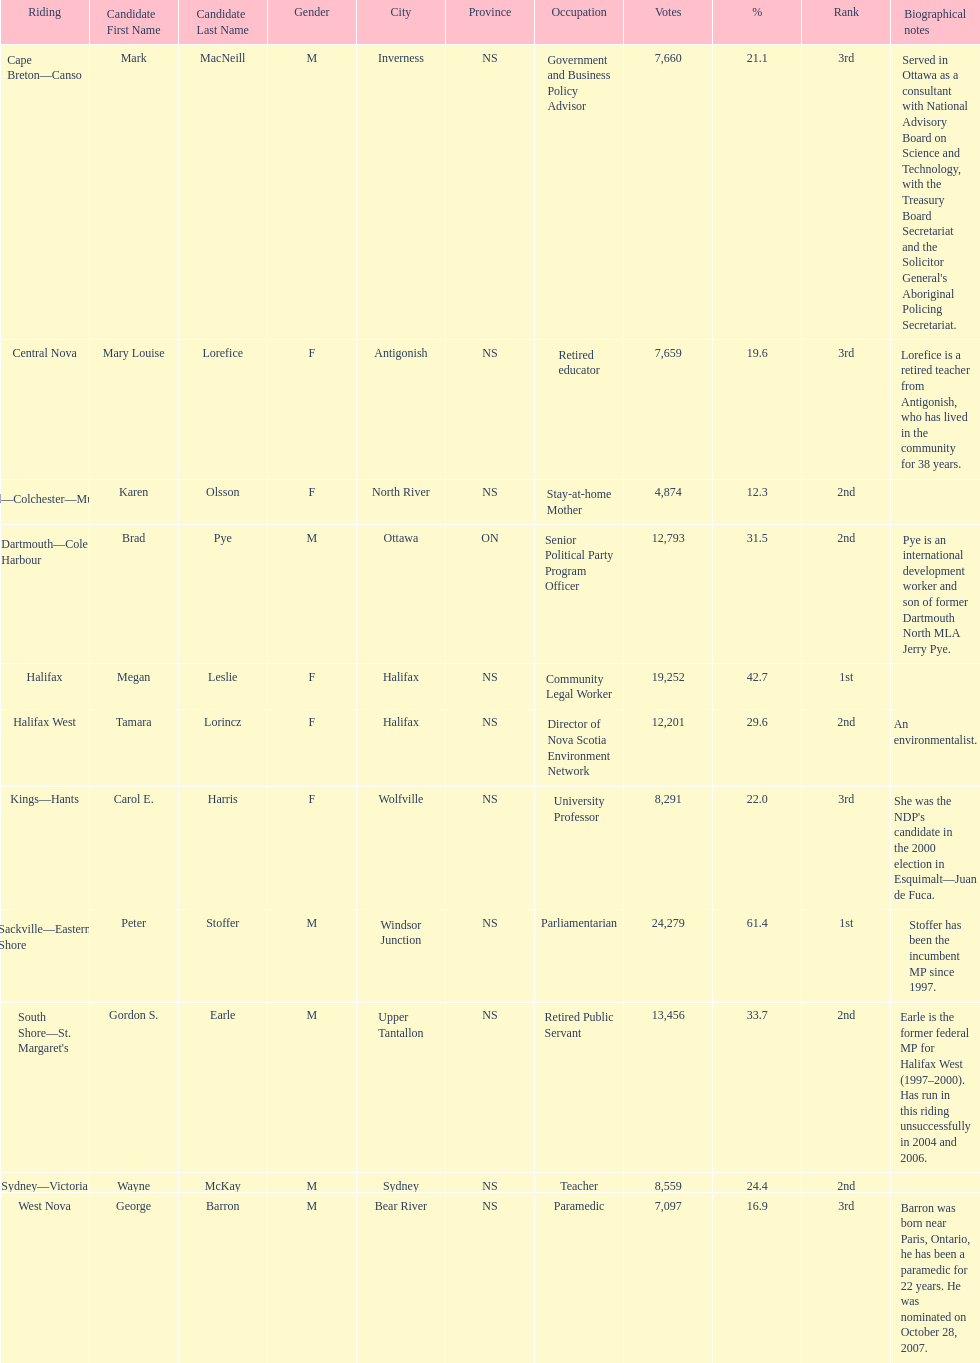How many of the candidates were females? 5. 